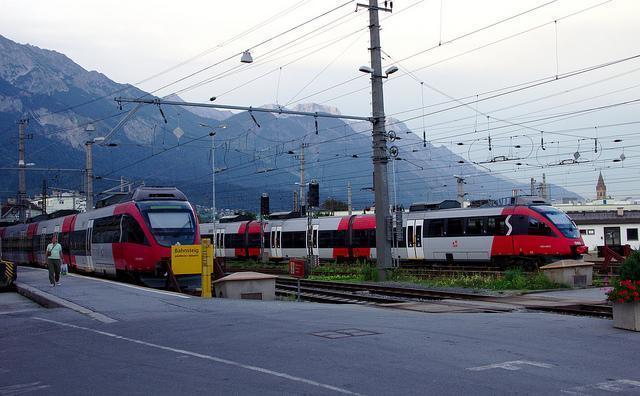What helps for transponders to communicate with the cab and train control systems?
Indicate the correct response by choosing from the four available options to answer the question.
Options: Network, wire, signal, cab. Signal. 